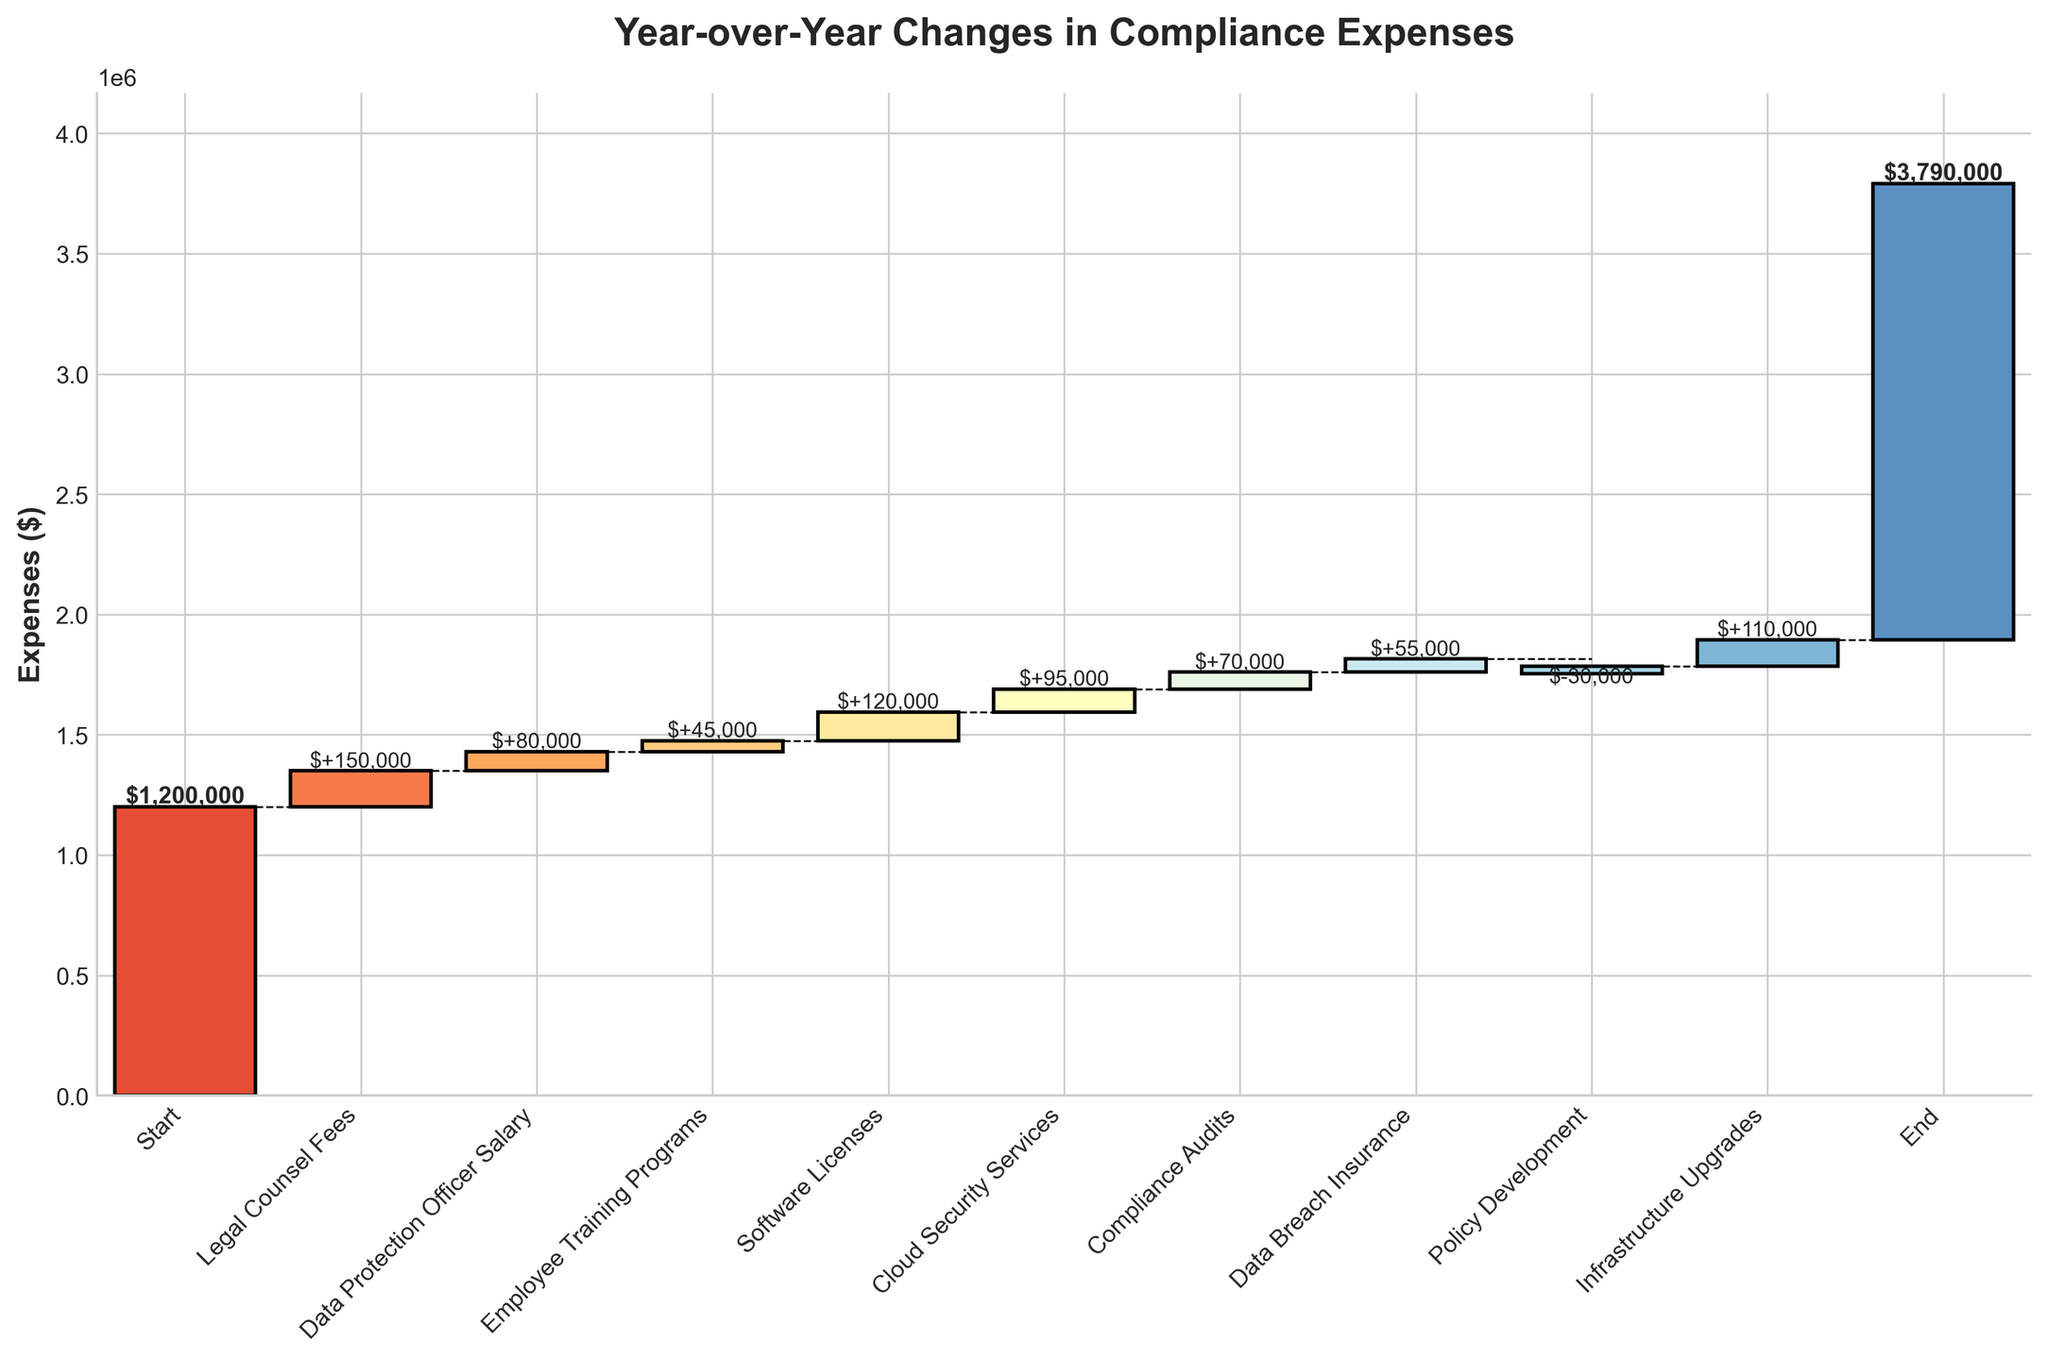What is the starting compliance expense amount? The starting compliance expense amount is indicated by the first bar in the chart, labeled "Start".
Answer: $1,200,000 How much did the Compliance Audits category contribute to the total expenses? The "Compliance Audits" category is represented by a single bar. The value associated with this bar is $70,000.
Answer: $70,000 What is the total increase in compliance expenses due to "Legal Counsel Fees", "Data Protection Officer Salary", and "Employee Training Programs"? Sum the values for "Legal Counsel Fees" ($150,000), "Data Protection Officer Salary" ($80,000), and "Employee Training Programs" ($45,000): $150,000 + $80,000 + $45,000
Answer: $275,000 Which compliance expense category had a negative contribution? The only bar with a negative value is labeled "Policy Development".
Answer: Policy Development What is the final compliance expense amount at the end of the year? The final compliance expense amount is indicated by the last bar in the chart, labeled "End".
Answer: $1,895,000 How did the "Software Licenses" expenditure compare to "Cloud Security Services"? Compare the values of the bars labeled "Software Licenses" ($120,000) and "Cloud Security Services" ($95,000).
Answer: Software Licenses is higher What is the net increase in compliance expenses between the "Start" and "End" categories? The net increase is found by subtracting the starting amount from the ending amount: $1,895,000 - $1,200,000.
Answer: $695,000 Which category had the highest individual expense? Among the bars representing individual categories, "Legal Counsel Fees" has the highest expense at $150,000.
Answer: Legal Counsel Fees What is the cumulative expense amount just before the "End" value is added? Sum all category values from "Start" to "Infrastructure Upgrades". To find the cumulative expense just before "End": $1200000 + $150000 + $80000 + $45000 + $120000 + $95000 + $70000 + $55000 - $30000 + $110000.
Answer: $1,795,000 How much more did the company spend on "Infrastructure Upgrades" compared to "Data Breach Insurance"? Compare the values for "Infrastructure Upgrades" ($110,000) and "Data Breach Insurance" ($55,000): $110,000 - $55,000.
Answer: $55,000 